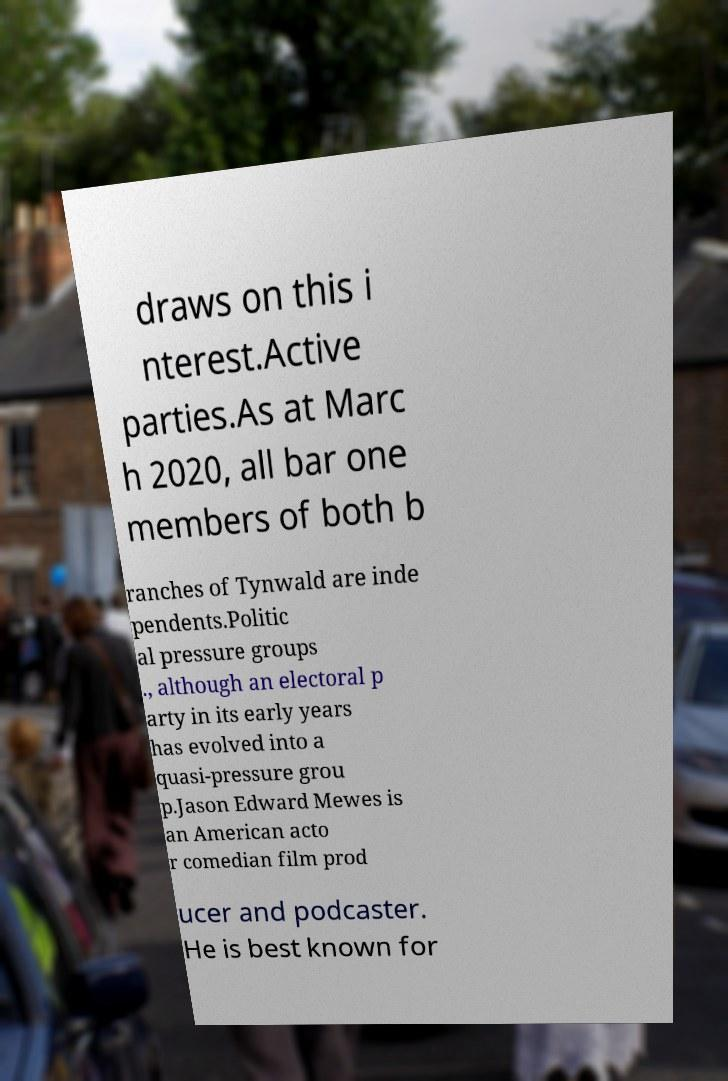Can you accurately transcribe the text from the provided image for me? draws on this i nterest.Active parties.As at Marc h 2020, all bar one members of both b ranches of Tynwald are inde pendents.Politic al pressure groups ., although an electoral p arty in its early years has evolved into a quasi-pressure grou p.Jason Edward Mewes is an American acto r comedian film prod ucer and podcaster. He is best known for 